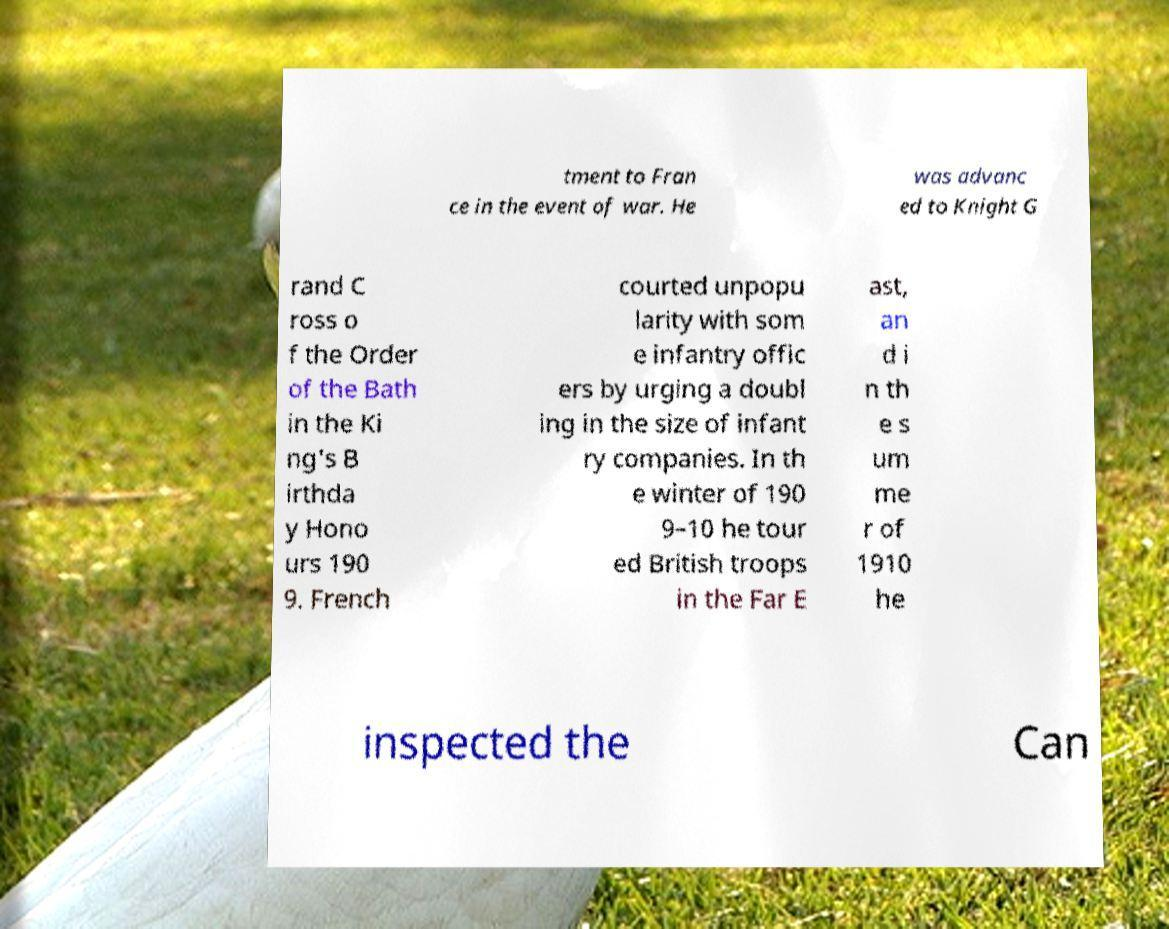Can you accurately transcribe the text from the provided image for me? tment to Fran ce in the event of war. He was advanc ed to Knight G rand C ross o f the Order of the Bath in the Ki ng's B irthda y Hono urs 190 9. French courted unpopu larity with som e infantry offic ers by urging a doubl ing in the size of infant ry companies. In th e winter of 190 9–10 he tour ed British troops in the Far E ast, an d i n th e s um me r of 1910 he inspected the Can 